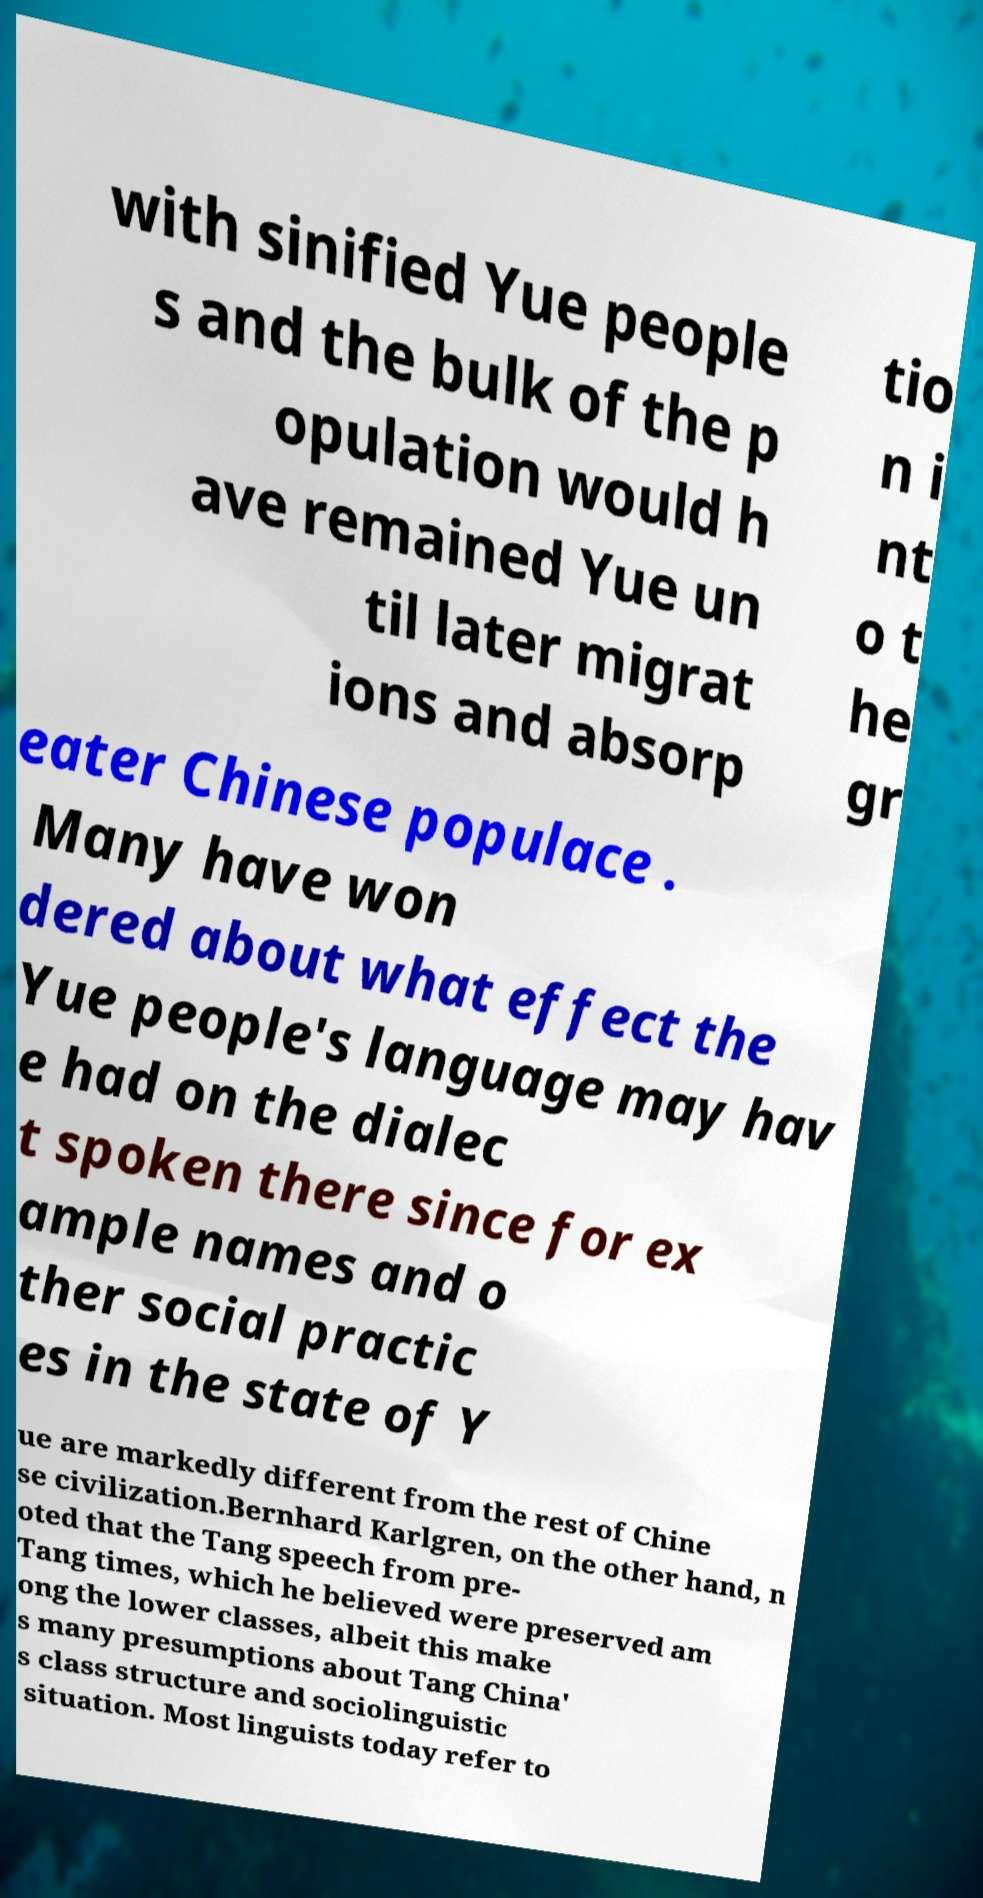Please identify and transcribe the text found in this image. with sinified Yue people s and the bulk of the p opulation would h ave remained Yue un til later migrat ions and absorp tio n i nt o t he gr eater Chinese populace . Many have won dered about what effect the Yue people's language may hav e had on the dialec t spoken there since for ex ample names and o ther social practic es in the state of Y ue are markedly different from the rest of Chine se civilization.Bernhard Karlgren, on the other hand, n oted that the Tang speech from pre- Tang times, which he believed were preserved am ong the lower classes, albeit this make s many presumptions about Tang China' s class structure and sociolinguistic situation. Most linguists today refer to 